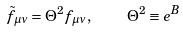<formula> <loc_0><loc_0><loc_500><loc_500>\tilde { f } _ { \mu \nu } = \Theta ^ { 2 } f _ { \mu \nu } , \quad \Theta ^ { 2 } \equiv e ^ { B }</formula> 